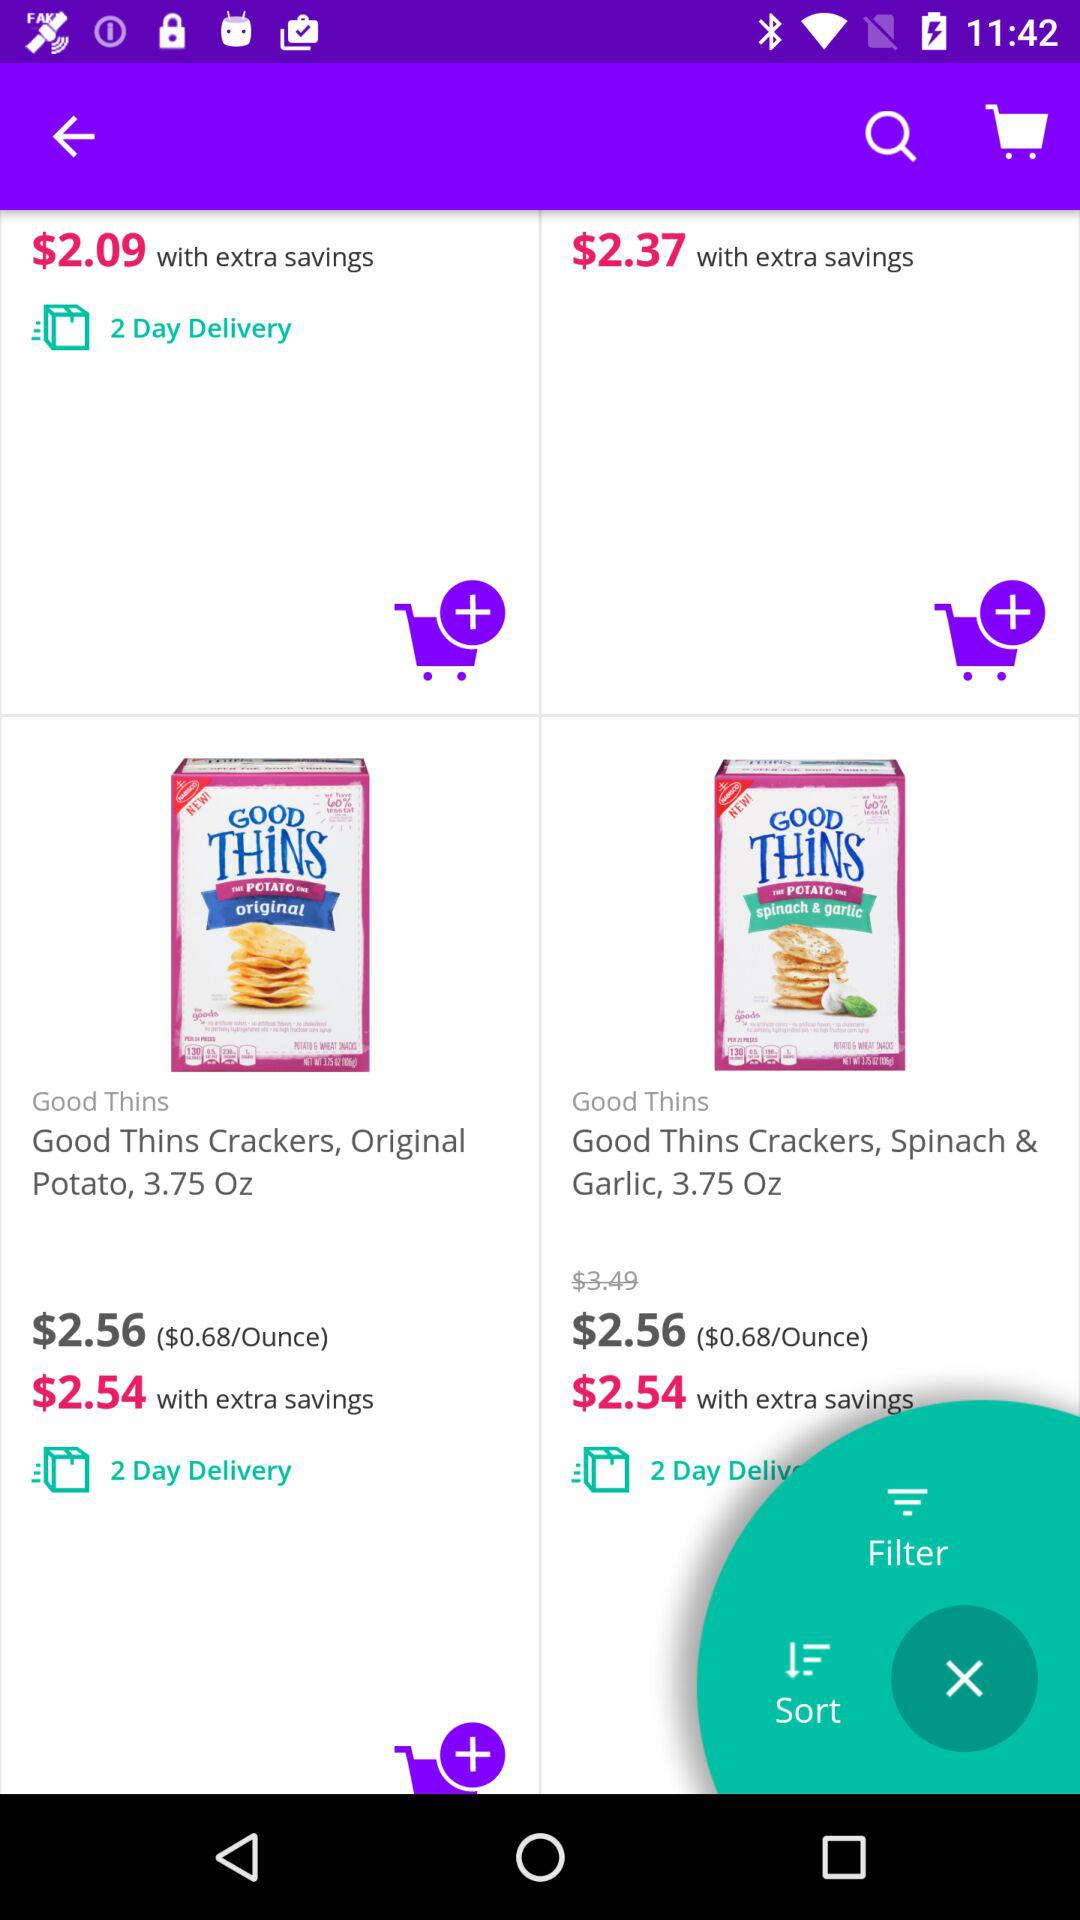What is the price of "Good Thins Crackers, Spinach & Garlic" with extra savings? The price with extra savings is $2.54. 